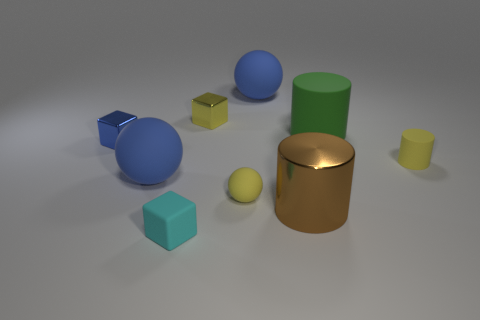How many blue balls must be subtracted to get 1 blue balls? 1 Add 1 large objects. How many objects exist? 10 Subtract all cylinders. How many objects are left? 6 Add 8 small blue metallic objects. How many small blue metallic objects are left? 9 Add 3 balls. How many balls exist? 6 Subtract 0 blue cylinders. How many objects are left? 9 Subtract all big green shiny cylinders. Subtract all cyan matte cubes. How many objects are left? 8 